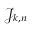<formula> <loc_0><loc_0><loc_500><loc_500>{ \mathcal { J } } _ { k , n }</formula> 